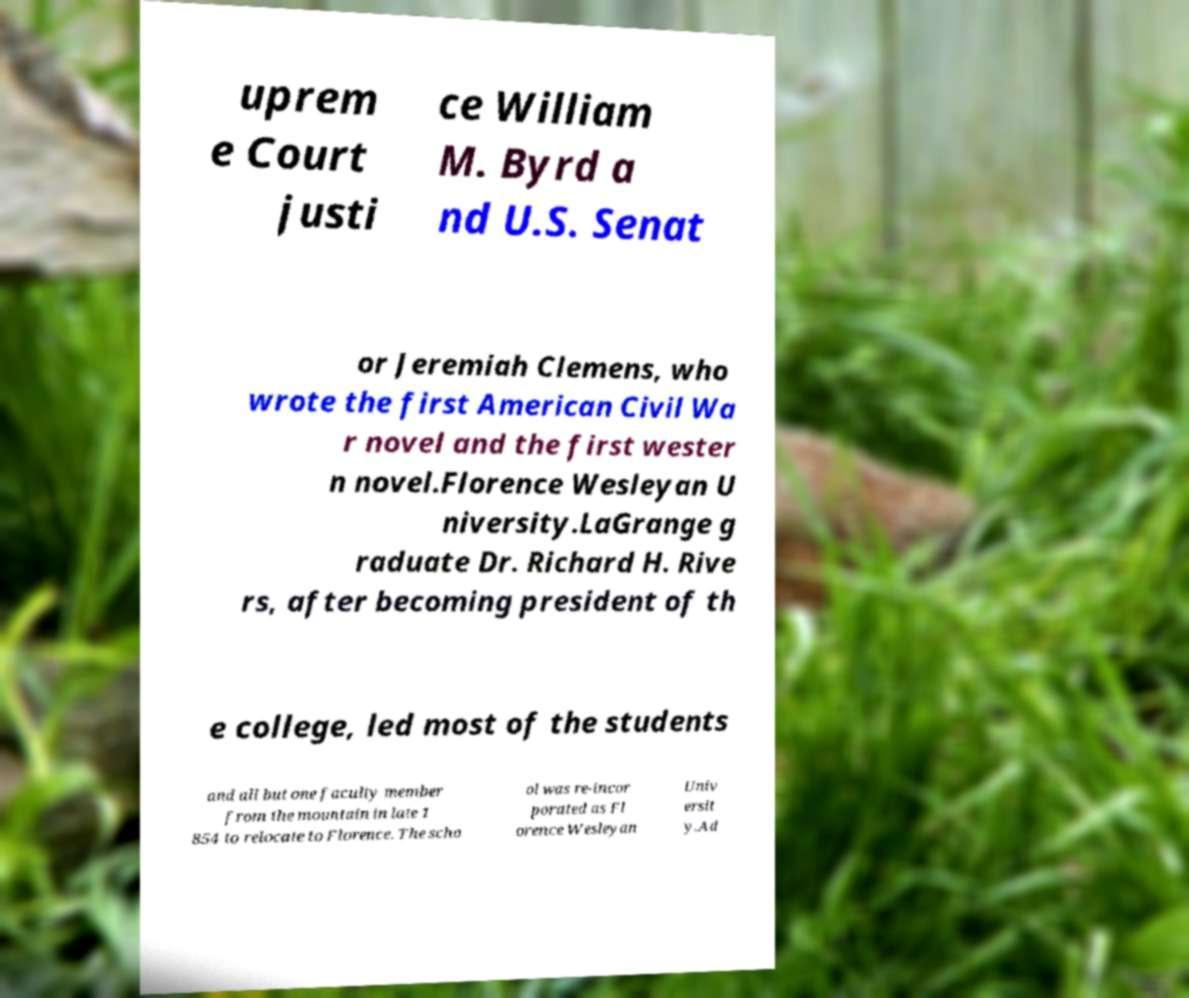For documentation purposes, I need the text within this image transcribed. Could you provide that? uprem e Court justi ce William M. Byrd a nd U.S. Senat or Jeremiah Clemens, who wrote the first American Civil Wa r novel and the first wester n novel.Florence Wesleyan U niversity.LaGrange g raduate Dr. Richard H. Rive rs, after becoming president of th e college, led most of the students and all but one faculty member from the mountain in late 1 854 to relocate to Florence. The scho ol was re-incor porated as Fl orence Wesleyan Univ ersit y.Ad 